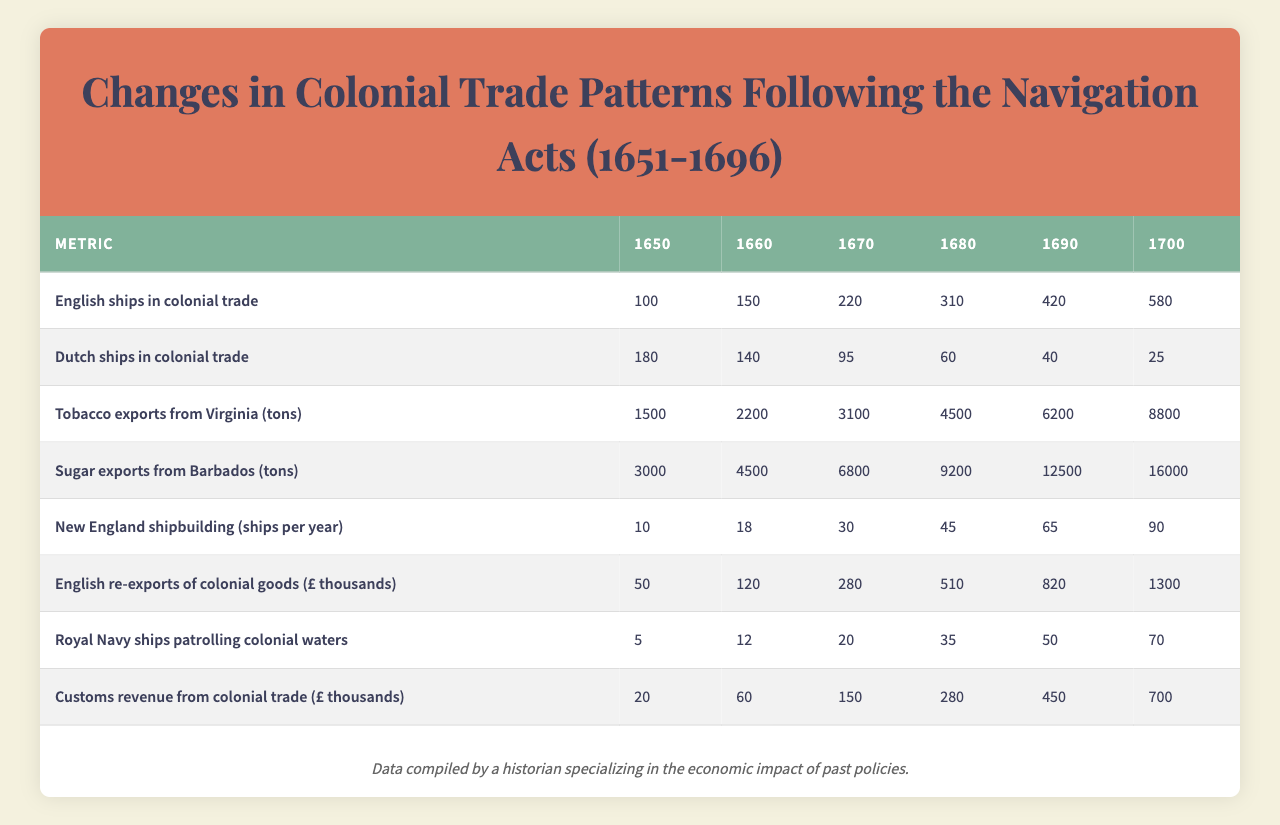What was the number of English ships in colonial trade in 1680? Referring to the table under the metric "English ships in colonial trade," the value for the year 1680 is listed as 310.
Answer: 310 How many Dutch ships were involved in colonial trade in 1660? Looking at the metric "Dutch ships in colonial trade" for the year 1660, the table shows a value of 140.
Answer: 140 What was the total amount of tobacco exports from Virginia in 1690? The table indicates that the tobacco exports from Virginia in 1690 is 6200 tons according to the respective metric.
Answer: 6200 tons What was the average number of English ships in colonial trade between 1650 and 1700? To calculate the average, sum the values for the years from 1650 to 1700: 100 + 150 + 220 + 310 + 420 + 580 = 1780, then divide by 6 to get the average, which is 1780 / 6 = approximately 296.67.
Answer: 296.67 Which metric showed the most significant increase from 1650 to 1700, and what was that increase? Analyzing the table, "English ships in colonial trade" increased from 100 in 1650 to 580 in 1700, showing an increase of 480. In contrast, "Dutch ships in colonial trade" decreased, so "English ships" had the largest increase.
Answer: English ships; increase of 480 How many more tons of sugar were exported from Barbados in 1690 compared to 1650? From the table, sugar exports in 1690 were 12500 tons and in 1650 were 3000 tons. The difference is calculated by subtracting: 12500 - 3000 = 9500 tons.
Answer: 9500 tons Did the customs revenue from colonial trade exceed £100 thousand in 1690? Checking the table, the customs revenue for 1690 is listed as £450 thousand, meaning it did exceed £100 thousand.
Answer: Yes What was the total number of Royal Navy ships patrolling colonial waters by 1700? The table indicates that for the year 1700, there were 70 Royal Navy ships patrolling colonial waters.
Answer: 70 Which metric had the highest value in 1680, and what was that value? Looking across the metrics for 1680, "Sugar exports from Barbados" had the highest value at 9200 tons.
Answer: Sugar exports; 9200 tons What was the increase in the number of ships built per year in New England from 1670 to 1700? The table shows that the number of New England ships built per year in 1670 was 30 and in 1700 it rose to 90. The increase is calculated as 90 - 30 = 60 ships.
Answer: 60 ships How did the amount of English re-exports of colonial goods change from 1650 to 1690? The value for English re-exports in 1650 was £50 thousand and in 1690 it was £820 thousand. The increase is £820 - £50 = £770 thousand, indicating substantial growth.
Answer: Increased by £770 thousand 